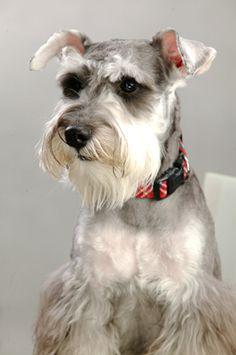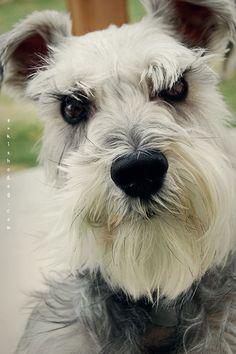The first image is the image on the left, the second image is the image on the right. For the images displayed, is the sentence "In one of the images a dog can be seen wearing a collar." factually correct? Answer yes or no. Yes. 